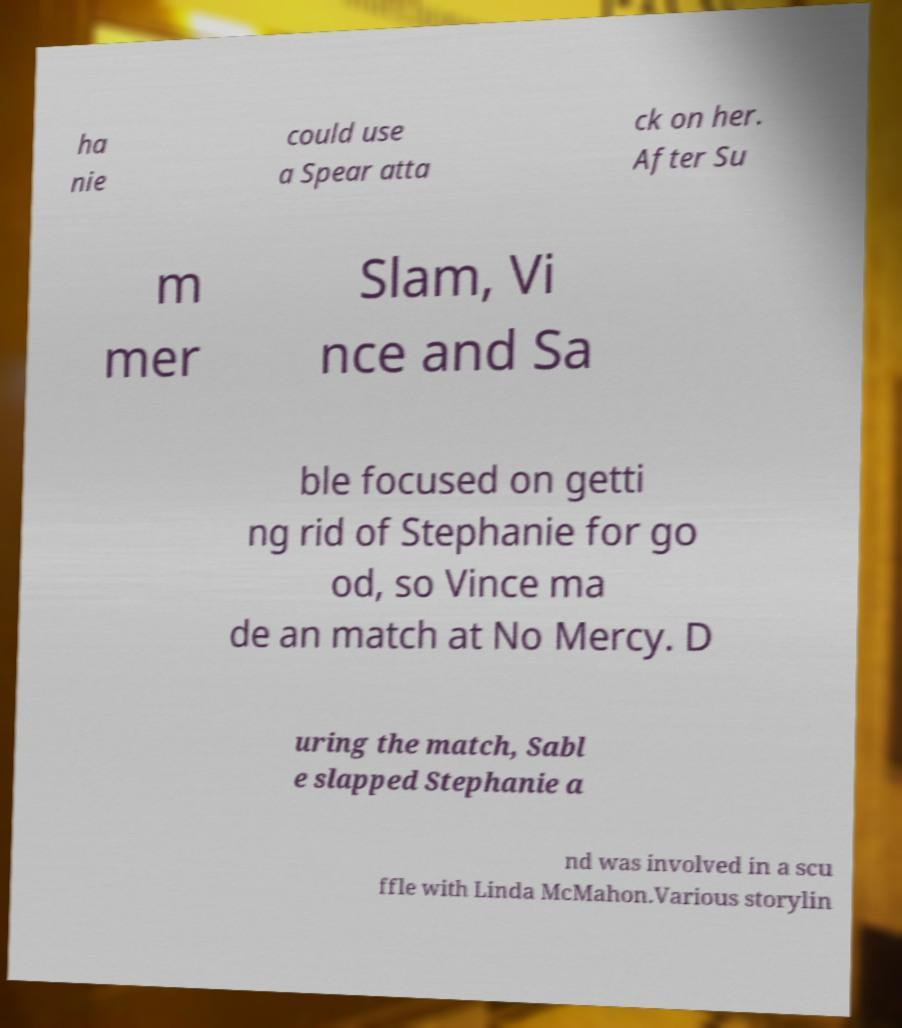Please identify and transcribe the text found in this image. ha nie could use a Spear atta ck on her. After Su m mer Slam, Vi nce and Sa ble focused on getti ng rid of Stephanie for go od, so Vince ma de an match at No Mercy. D uring the match, Sabl e slapped Stephanie a nd was involved in a scu ffle with Linda McMahon.Various storylin 